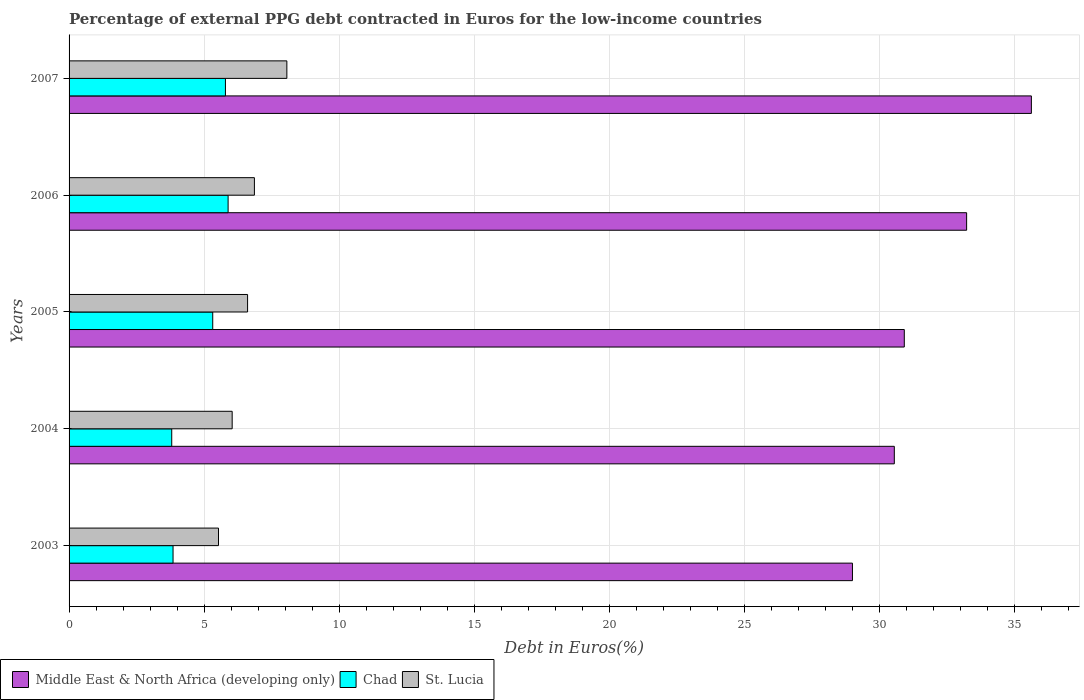Are the number of bars on each tick of the Y-axis equal?
Make the answer very short. Yes. How many bars are there on the 2nd tick from the top?
Offer a terse response. 3. How many bars are there on the 2nd tick from the bottom?
Provide a short and direct response. 3. What is the label of the 5th group of bars from the top?
Your answer should be very brief. 2003. In how many cases, is the number of bars for a given year not equal to the number of legend labels?
Give a very brief answer. 0. What is the percentage of external PPG debt contracted in Euros in Middle East & North Africa (developing only) in 2006?
Your answer should be very brief. 33.24. Across all years, what is the maximum percentage of external PPG debt contracted in Euros in Middle East & North Africa (developing only)?
Offer a terse response. 35.64. Across all years, what is the minimum percentage of external PPG debt contracted in Euros in Middle East & North Africa (developing only)?
Your answer should be very brief. 29.01. In which year was the percentage of external PPG debt contracted in Euros in Middle East & North Africa (developing only) minimum?
Your answer should be compact. 2003. What is the total percentage of external PPG debt contracted in Euros in Chad in the graph?
Offer a terse response. 24.66. What is the difference between the percentage of external PPG debt contracted in Euros in Middle East & North Africa (developing only) in 2005 and that in 2006?
Keep it short and to the point. -2.31. What is the difference between the percentage of external PPG debt contracted in Euros in Chad in 2007 and the percentage of external PPG debt contracted in Euros in Middle East & North Africa (developing only) in 2003?
Your response must be concise. -23.22. What is the average percentage of external PPG debt contracted in Euros in Middle East & North Africa (developing only) per year?
Provide a short and direct response. 31.88. In the year 2003, what is the difference between the percentage of external PPG debt contracted in Euros in St. Lucia and percentage of external PPG debt contracted in Euros in Chad?
Offer a very short reply. 1.68. What is the ratio of the percentage of external PPG debt contracted in Euros in St. Lucia in 2004 to that in 2007?
Keep it short and to the point. 0.75. Is the percentage of external PPG debt contracted in Euros in Chad in 2003 less than that in 2007?
Offer a terse response. Yes. What is the difference between the highest and the second highest percentage of external PPG debt contracted in Euros in St. Lucia?
Your answer should be compact. 1.2. What is the difference between the highest and the lowest percentage of external PPG debt contracted in Euros in St. Lucia?
Keep it short and to the point. 2.53. What does the 3rd bar from the top in 2003 represents?
Give a very brief answer. Middle East & North Africa (developing only). What does the 3rd bar from the bottom in 2006 represents?
Keep it short and to the point. St. Lucia. Are all the bars in the graph horizontal?
Offer a very short reply. Yes. Are the values on the major ticks of X-axis written in scientific E-notation?
Provide a short and direct response. No. Does the graph contain any zero values?
Keep it short and to the point. No. Does the graph contain grids?
Provide a short and direct response. Yes. Where does the legend appear in the graph?
Your answer should be compact. Bottom left. What is the title of the graph?
Provide a succinct answer. Percentage of external PPG debt contracted in Euros for the low-income countries. Does "Europe(all income levels)" appear as one of the legend labels in the graph?
Make the answer very short. No. What is the label or title of the X-axis?
Offer a terse response. Debt in Euros(%). What is the Debt in Euros(%) of Middle East & North Africa (developing only) in 2003?
Your answer should be compact. 29.01. What is the Debt in Euros(%) of Chad in 2003?
Give a very brief answer. 3.85. What is the Debt in Euros(%) of St. Lucia in 2003?
Give a very brief answer. 5.53. What is the Debt in Euros(%) in Middle East & North Africa (developing only) in 2004?
Keep it short and to the point. 30.56. What is the Debt in Euros(%) in Chad in 2004?
Your answer should be compact. 3.8. What is the Debt in Euros(%) in St. Lucia in 2004?
Your answer should be compact. 6.04. What is the Debt in Euros(%) of Middle East & North Africa (developing only) in 2005?
Offer a terse response. 30.93. What is the Debt in Euros(%) of Chad in 2005?
Your answer should be compact. 5.32. What is the Debt in Euros(%) of St. Lucia in 2005?
Provide a succinct answer. 6.61. What is the Debt in Euros(%) of Middle East & North Africa (developing only) in 2006?
Offer a terse response. 33.24. What is the Debt in Euros(%) of Chad in 2006?
Give a very brief answer. 5.89. What is the Debt in Euros(%) in St. Lucia in 2006?
Ensure brevity in your answer.  6.86. What is the Debt in Euros(%) of Middle East & North Africa (developing only) in 2007?
Offer a very short reply. 35.64. What is the Debt in Euros(%) in Chad in 2007?
Make the answer very short. 5.79. What is the Debt in Euros(%) in St. Lucia in 2007?
Offer a very short reply. 8.07. Across all years, what is the maximum Debt in Euros(%) of Middle East & North Africa (developing only)?
Offer a terse response. 35.64. Across all years, what is the maximum Debt in Euros(%) of Chad?
Keep it short and to the point. 5.89. Across all years, what is the maximum Debt in Euros(%) in St. Lucia?
Provide a short and direct response. 8.07. Across all years, what is the minimum Debt in Euros(%) in Middle East & North Africa (developing only)?
Your answer should be compact. 29.01. Across all years, what is the minimum Debt in Euros(%) in Chad?
Ensure brevity in your answer.  3.8. Across all years, what is the minimum Debt in Euros(%) in St. Lucia?
Give a very brief answer. 5.53. What is the total Debt in Euros(%) of Middle East & North Africa (developing only) in the graph?
Provide a short and direct response. 159.4. What is the total Debt in Euros(%) in Chad in the graph?
Provide a succinct answer. 24.66. What is the total Debt in Euros(%) of St. Lucia in the graph?
Provide a short and direct response. 33.12. What is the difference between the Debt in Euros(%) of Middle East & North Africa (developing only) in 2003 and that in 2004?
Ensure brevity in your answer.  -1.55. What is the difference between the Debt in Euros(%) in Chad in 2003 and that in 2004?
Your answer should be compact. 0.05. What is the difference between the Debt in Euros(%) of St. Lucia in 2003 and that in 2004?
Make the answer very short. -0.51. What is the difference between the Debt in Euros(%) in Middle East & North Africa (developing only) in 2003 and that in 2005?
Your response must be concise. -1.92. What is the difference between the Debt in Euros(%) of Chad in 2003 and that in 2005?
Make the answer very short. -1.47. What is the difference between the Debt in Euros(%) in St. Lucia in 2003 and that in 2005?
Make the answer very short. -1.08. What is the difference between the Debt in Euros(%) in Middle East & North Africa (developing only) in 2003 and that in 2006?
Provide a succinct answer. -4.23. What is the difference between the Debt in Euros(%) in Chad in 2003 and that in 2006?
Keep it short and to the point. -2.04. What is the difference between the Debt in Euros(%) in St. Lucia in 2003 and that in 2006?
Provide a short and direct response. -1.33. What is the difference between the Debt in Euros(%) in Middle East & North Africa (developing only) in 2003 and that in 2007?
Offer a terse response. -6.63. What is the difference between the Debt in Euros(%) in Chad in 2003 and that in 2007?
Ensure brevity in your answer.  -1.94. What is the difference between the Debt in Euros(%) of St. Lucia in 2003 and that in 2007?
Your response must be concise. -2.53. What is the difference between the Debt in Euros(%) in Middle East & North Africa (developing only) in 2004 and that in 2005?
Keep it short and to the point. -0.37. What is the difference between the Debt in Euros(%) in Chad in 2004 and that in 2005?
Your response must be concise. -1.52. What is the difference between the Debt in Euros(%) of St. Lucia in 2004 and that in 2005?
Give a very brief answer. -0.57. What is the difference between the Debt in Euros(%) in Middle East & North Africa (developing only) in 2004 and that in 2006?
Provide a short and direct response. -2.68. What is the difference between the Debt in Euros(%) in Chad in 2004 and that in 2006?
Keep it short and to the point. -2.09. What is the difference between the Debt in Euros(%) in St. Lucia in 2004 and that in 2006?
Provide a short and direct response. -0.82. What is the difference between the Debt in Euros(%) of Middle East & North Africa (developing only) in 2004 and that in 2007?
Provide a short and direct response. -5.08. What is the difference between the Debt in Euros(%) of Chad in 2004 and that in 2007?
Give a very brief answer. -1.99. What is the difference between the Debt in Euros(%) in St. Lucia in 2004 and that in 2007?
Provide a succinct answer. -2.03. What is the difference between the Debt in Euros(%) in Middle East & North Africa (developing only) in 2005 and that in 2006?
Ensure brevity in your answer.  -2.31. What is the difference between the Debt in Euros(%) in Chad in 2005 and that in 2006?
Make the answer very short. -0.57. What is the difference between the Debt in Euros(%) in St. Lucia in 2005 and that in 2006?
Provide a succinct answer. -0.25. What is the difference between the Debt in Euros(%) in Middle East & North Africa (developing only) in 2005 and that in 2007?
Offer a very short reply. -4.71. What is the difference between the Debt in Euros(%) of Chad in 2005 and that in 2007?
Offer a terse response. -0.47. What is the difference between the Debt in Euros(%) in St. Lucia in 2005 and that in 2007?
Offer a terse response. -1.46. What is the difference between the Debt in Euros(%) of Middle East & North Africa (developing only) in 2006 and that in 2007?
Make the answer very short. -2.4. What is the difference between the Debt in Euros(%) in Chad in 2006 and that in 2007?
Make the answer very short. 0.1. What is the difference between the Debt in Euros(%) in St. Lucia in 2006 and that in 2007?
Offer a very short reply. -1.2. What is the difference between the Debt in Euros(%) of Middle East & North Africa (developing only) in 2003 and the Debt in Euros(%) of Chad in 2004?
Provide a succinct answer. 25.21. What is the difference between the Debt in Euros(%) of Middle East & North Africa (developing only) in 2003 and the Debt in Euros(%) of St. Lucia in 2004?
Offer a terse response. 22.97. What is the difference between the Debt in Euros(%) of Chad in 2003 and the Debt in Euros(%) of St. Lucia in 2004?
Make the answer very short. -2.19. What is the difference between the Debt in Euros(%) of Middle East & North Africa (developing only) in 2003 and the Debt in Euros(%) of Chad in 2005?
Your answer should be very brief. 23.69. What is the difference between the Debt in Euros(%) in Middle East & North Africa (developing only) in 2003 and the Debt in Euros(%) in St. Lucia in 2005?
Ensure brevity in your answer.  22.4. What is the difference between the Debt in Euros(%) in Chad in 2003 and the Debt in Euros(%) in St. Lucia in 2005?
Give a very brief answer. -2.76. What is the difference between the Debt in Euros(%) in Middle East & North Africa (developing only) in 2003 and the Debt in Euros(%) in Chad in 2006?
Your answer should be compact. 23.12. What is the difference between the Debt in Euros(%) of Middle East & North Africa (developing only) in 2003 and the Debt in Euros(%) of St. Lucia in 2006?
Offer a terse response. 22.15. What is the difference between the Debt in Euros(%) in Chad in 2003 and the Debt in Euros(%) in St. Lucia in 2006?
Offer a very short reply. -3.01. What is the difference between the Debt in Euros(%) of Middle East & North Africa (developing only) in 2003 and the Debt in Euros(%) of Chad in 2007?
Offer a very short reply. 23.22. What is the difference between the Debt in Euros(%) in Middle East & North Africa (developing only) in 2003 and the Debt in Euros(%) in St. Lucia in 2007?
Give a very brief answer. 20.95. What is the difference between the Debt in Euros(%) of Chad in 2003 and the Debt in Euros(%) of St. Lucia in 2007?
Your answer should be compact. -4.22. What is the difference between the Debt in Euros(%) of Middle East & North Africa (developing only) in 2004 and the Debt in Euros(%) of Chad in 2005?
Keep it short and to the point. 25.24. What is the difference between the Debt in Euros(%) of Middle East & North Africa (developing only) in 2004 and the Debt in Euros(%) of St. Lucia in 2005?
Your answer should be compact. 23.95. What is the difference between the Debt in Euros(%) in Chad in 2004 and the Debt in Euros(%) in St. Lucia in 2005?
Give a very brief answer. -2.81. What is the difference between the Debt in Euros(%) in Middle East & North Africa (developing only) in 2004 and the Debt in Euros(%) in Chad in 2006?
Ensure brevity in your answer.  24.67. What is the difference between the Debt in Euros(%) of Middle East & North Africa (developing only) in 2004 and the Debt in Euros(%) of St. Lucia in 2006?
Provide a short and direct response. 23.7. What is the difference between the Debt in Euros(%) in Chad in 2004 and the Debt in Euros(%) in St. Lucia in 2006?
Make the answer very short. -3.06. What is the difference between the Debt in Euros(%) of Middle East & North Africa (developing only) in 2004 and the Debt in Euros(%) of Chad in 2007?
Provide a succinct answer. 24.77. What is the difference between the Debt in Euros(%) in Middle East & North Africa (developing only) in 2004 and the Debt in Euros(%) in St. Lucia in 2007?
Your answer should be compact. 22.5. What is the difference between the Debt in Euros(%) in Chad in 2004 and the Debt in Euros(%) in St. Lucia in 2007?
Your answer should be very brief. -4.26. What is the difference between the Debt in Euros(%) in Middle East & North Africa (developing only) in 2005 and the Debt in Euros(%) in Chad in 2006?
Ensure brevity in your answer.  25.04. What is the difference between the Debt in Euros(%) in Middle East & North Africa (developing only) in 2005 and the Debt in Euros(%) in St. Lucia in 2006?
Your answer should be compact. 24.07. What is the difference between the Debt in Euros(%) of Chad in 2005 and the Debt in Euros(%) of St. Lucia in 2006?
Keep it short and to the point. -1.54. What is the difference between the Debt in Euros(%) in Middle East & North Africa (developing only) in 2005 and the Debt in Euros(%) in Chad in 2007?
Keep it short and to the point. 25.14. What is the difference between the Debt in Euros(%) of Middle East & North Africa (developing only) in 2005 and the Debt in Euros(%) of St. Lucia in 2007?
Your answer should be compact. 22.87. What is the difference between the Debt in Euros(%) of Chad in 2005 and the Debt in Euros(%) of St. Lucia in 2007?
Offer a very short reply. -2.75. What is the difference between the Debt in Euros(%) in Middle East & North Africa (developing only) in 2006 and the Debt in Euros(%) in Chad in 2007?
Make the answer very short. 27.45. What is the difference between the Debt in Euros(%) in Middle East & North Africa (developing only) in 2006 and the Debt in Euros(%) in St. Lucia in 2007?
Provide a succinct answer. 25.18. What is the difference between the Debt in Euros(%) in Chad in 2006 and the Debt in Euros(%) in St. Lucia in 2007?
Your answer should be compact. -2.18. What is the average Debt in Euros(%) in Middle East & North Africa (developing only) per year?
Ensure brevity in your answer.  31.88. What is the average Debt in Euros(%) of Chad per year?
Give a very brief answer. 4.93. What is the average Debt in Euros(%) in St. Lucia per year?
Offer a terse response. 6.62. In the year 2003, what is the difference between the Debt in Euros(%) in Middle East & North Africa (developing only) and Debt in Euros(%) in Chad?
Your response must be concise. 25.16. In the year 2003, what is the difference between the Debt in Euros(%) of Middle East & North Africa (developing only) and Debt in Euros(%) of St. Lucia?
Provide a short and direct response. 23.48. In the year 2003, what is the difference between the Debt in Euros(%) in Chad and Debt in Euros(%) in St. Lucia?
Offer a terse response. -1.68. In the year 2004, what is the difference between the Debt in Euros(%) of Middle East & North Africa (developing only) and Debt in Euros(%) of Chad?
Make the answer very short. 26.76. In the year 2004, what is the difference between the Debt in Euros(%) of Middle East & North Africa (developing only) and Debt in Euros(%) of St. Lucia?
Your answer should be very brief. 24.52. In the year 2004, what is the difference between the Debt in Euros(%) of Chad and Debt in Euros(%) of St. Lucia?
Offer a very short reply. -2.24. In the year 2005, what is the difference between the Debt in Euros(%) of Middle East & North Africa (developing only) and Debt in Euros(%) of Chad?
Provide a short and direct response. 25.61. In the year 2005, what is the difference between the Debt in Euros(%) in Middle East & North Africa (developing only) and Debt in Euros(%) in St. Lucia?
Offer a very short reply. 24.32. In the year 2005, what is the difference between the Debt in Euros(%) in Chad and Debt in Euros(%) in St. Lucia?
Offer a very short reply. -1.29. In the year 2006, what is the difference between the Debt in Euros(%) of Middle East & North Africa (developing only) and Debt in Euros(%) of Chad?
Give a very brief answer. 27.35. In the year 2006, what is the difference between the Debt in Euros(%) in Middle East & North Africa (developing only) and Debt in Euros(%) in St. Lucia?
Your answer should be compact. 26.38. In the year 2006, what is the difference between the Debt in Euros(%) in Chad and Debt in Euros(%) in St. Lucia?
Make the answer very short. -0.97. In the year 2007, what is the difference between the Debt in Euros(%) in Middle East & North Africa (developing only) and Debt in Euros(%) in Chad?
Make the answer very short. 29.85. In the year 2007, what is the difference between the Debt in Euros(%) in Middle East & North Africa (developing only) and Debt in Euros(%) in St. Lucia?
Offer a very short reply. 27.57. In the year 2007, what is the difference between the Debt in Euros(%) in Chad and Debt in Euros(%) in St. Lucia?
Provide a short and direct response. -2.28. What is the ratio of the Debt in Euros(%) in Middle East & North Africa (developing only) in 2003 to that in 2004?
Your response must be concise. 0.95. What is the ratio of the Debt in Euros(%) of Chad in 2003 to that in 2004?
Make the answer very short. 1.01. What is the ratio of the Debt in Euros(%) in St. Lucia in 2003 to that in 2004?
Provide a succinct answer. 0.92. What is the ratio of the Debt in Euros(%) of Middle East & North Africa (developing only) in 2003 to that in 2005?
Provide a succinct answer. 0.94. What is the ratio of the Debt in Euros(%) in Chad in 2003 to that in 2005?
Your response must be concise. 0.72. What is the ratio of the Debt in Euros(%) in St. Lucia in 2003 to that in 2005?
Provide a short and direct response. 0.84. What is the ratio of the Debt in Euros(%) in Middle East & North Africa (developing only) in 2003 to that in 2006?
Give a very brief answer. 0.87. What is the ratio of the Debt in Euros(%) in Chad in 2003 to that in 2006?
Provide a succinct answer. 0.65. What is the ratio of the Debt in Euros(%) in St. Lucia in 2003 to that in 2006?
Ensure brevity in your answer.  0.81. What is the ratio of the Debt in Euros(%) of Middle East & North Africa (developing only) in 2003 to that in 2007?
Your answer should be very brief. 0.81. What is the ratio of the Debt in Euros(%) in Chad in 2003 to that in 2007?
Give a very brief answer. 0.67. What is the ratio of the Debt in Euros(%) of St. Lucia in 2003 to that in 2007?
Your response must be concise. 0.69. What is the ratio of the Debt in Euros(%) in Chad in 2004 to that in 2005?
Your answer should be compact. 0.71. What is the ratio of the Debt in Euros(%) in St. Lucia in 2004 to that in 2005?
Keep it short and to the point. 0.91. What is the ratio of the Debt in Euros(%) in Middle East & North Africa (developing only) in 2004 to that in 2006?
Offer a terse response. 0.92. What is the ratio of the Debt in Euros(%) of Chad in 2004 to that in 2006?
Give a very brief answer. 0.65. What is the ratio of the Debt in Euros(%) in Middle East & North Africa (developing only) in 2004 to that in 2007?
Keep it short and to the point. 0.86. What is the ratio of the Debt in Euros(%) of Chad in 2004 to that in 2007?
Provide a short and direct response. 0.66. What is the ratio of the Debt in Euros(%) of St. Lucia in 2004 to that in 2007?
Offer a very short reply. 0.75. What is the ratio of the Debt in Euros(%) of Middle East & North Africa (developing only) in 2005 to that in 2006?
Keep it short and to the point. 0.93. What is the ratio of the Debt in Euros(%) of Chad in 2005 to that in 2006?
Your answer should be very brief. 0.9. What is the ratio of the Debt in Euros(%) of St. Lucia in 2005 to that in 2006?
Your answer should be compact. 0.96. What is the ratio of the Debt in Euros(%) of Middle East & North Africa (developing only) in 2005 to that in 2007?
Give a very brief answer. 0.87. What is the ratio of the Debt in Euros(%) in Chad in 2005 to that in 2007?
Your response must be concise. 0.92. What is the ratio of the Debt in Euros(%) of St. Lucia in 2005 to that in 2007?
Your answer should be compact. 0.82. What is the ratio of the Debt in Euros(%) in Middle East & North Africa (developing only) in 2006 to that in 2007?
Give a very brief answer. 0.93. What is the ratio of the Debt in Euros(%) in Chad in 2006 to that in 2007?
Make the answer very short. 1.02. What is the ratio of the Debt in Euros(%) in St. Lucia in 2006 to that in 2007?
Your response must be concise. 0.85. What is the difference between the highest and the second highest Debt in Euros(%) of Middle East & North Africa (developing only)?
Give a very brief answer. 2.4. What is the difference between the highest and the second highest Debt in Euros(%) in Chad?
Offer a terse response. 0.1. What is the difference between the highest and the second highest Debt in Euros(%) of St. Lucia?
Provide a short and direct response. 1.2. What is the difference between the highest and the lowest Debt in Euros(%) of Middle East & North Africa (developing only)?
Keep it short and to the point. 6.63. What is the difference between the highest and the lowest Debt in Euros(%) in Chad?
Your response must be concise. 2.09. What is the difference between the highest and the lowest Debt in Euros(%) in St. Lucia?
Provide a short and direct response. 2.53. 